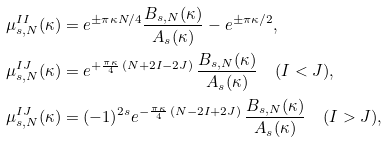Convert formula to latex. <formula><loc_0><loc_0><loc_500><loc_500>\mu ^ { I I } _ { s , N } ( \kappa ) & = e ^ { \pm \pi \kappa N / 4 } \frac { B _ { s , N } ( \kappa ) } { A _ { s } ( \kappa ) } - e ^ { \pm \pi \kappa / 2 } , \\ \mu ^ { I J } _ { s , N } ( \kappa ) & = e ^ { + \frac { \pi \kappa } { 4 } \, ( N + 2 I - 2 J ) } \, \frac { B _ { s , N } ( \kappa ) } { A _ { s } ( \kappa ) } \quad ( I < J ) , \\ \mu ^ { I J } _ { s , N } ( \kappa ) & = ( - 1 ) ^ { 2 s } e ^ { - \frac { \pi \kappa } { 4 } \, ( N - 2 I + 2 J ) } \, \frac { B _ { s , N } ( \kappa ) } { A _ { s } ( \kappa ) } \quad ( I > J ) ,</formula> 